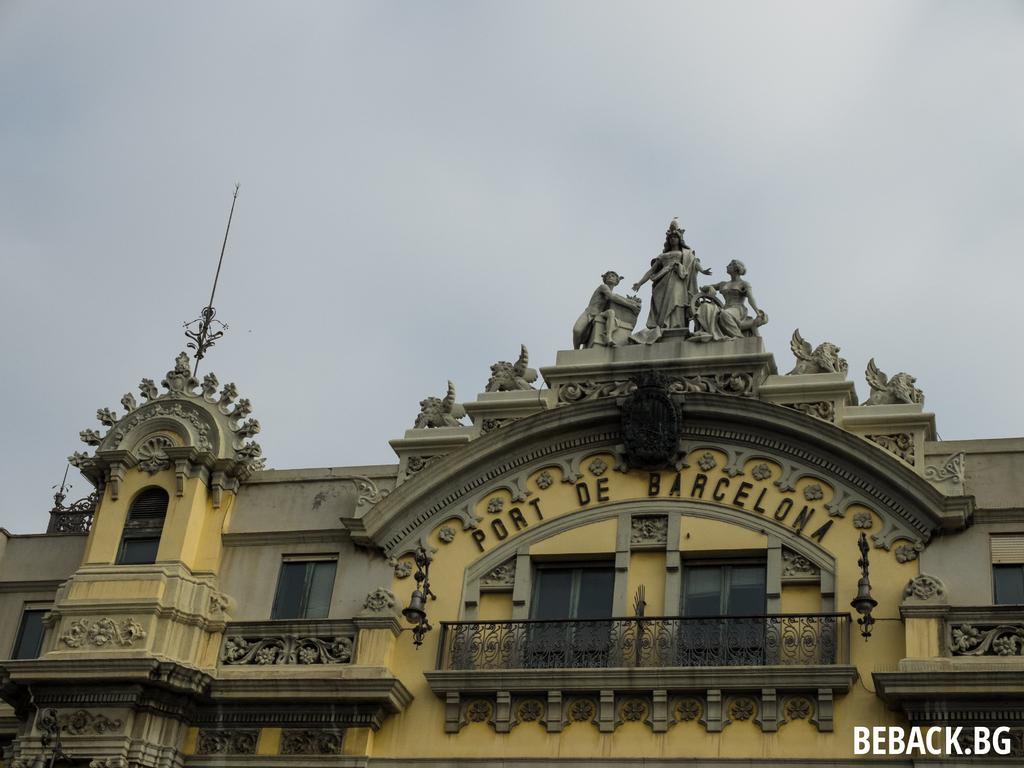What port is this?
Give a very brief answer. Port de barcelona. Which website featured this image?
Your answer should be very brief. Beback.bg. 